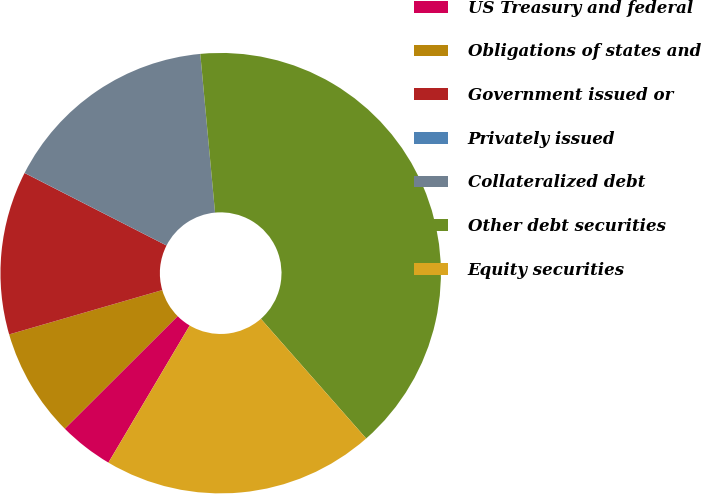Convert chart. <chart><loc_0><loc_0><loc_500><loc_500><pie_chart><fcel>US Treasury and federal<fcel>Obligations of states and<fcel>Government issued or<fcel>Privately issued<fcel>Collateralized debt<fcel>Other debt securities<fcel>Equity securities<nl><fcel>4.0%<fcel>8.0%<fcel>12.0%<fcel>0.01%<fcel>16.0%<fcel>39.99%<fcel>20.0%<nl></chart> 